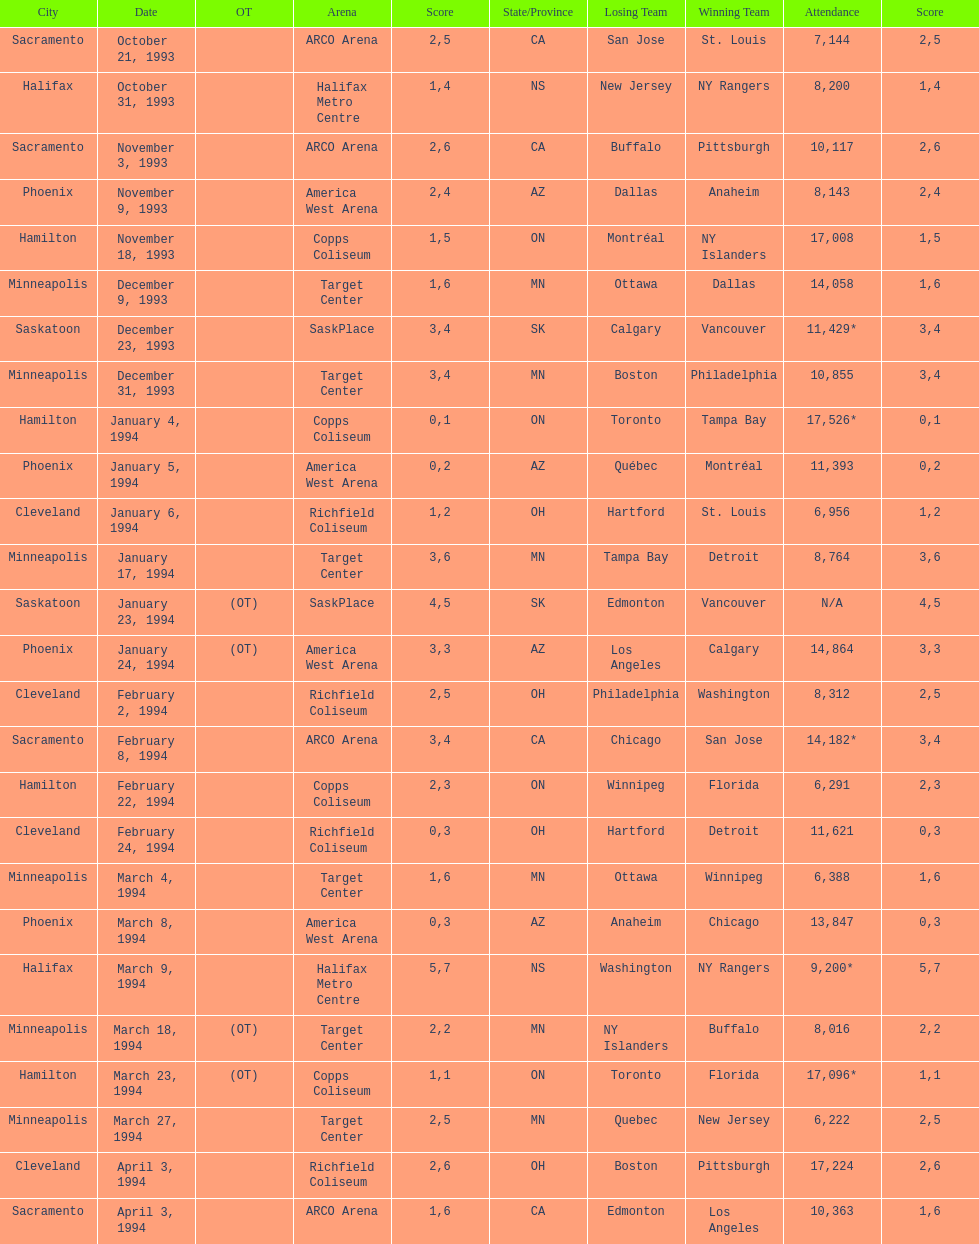How many games have been held in minneapolis? 6. 